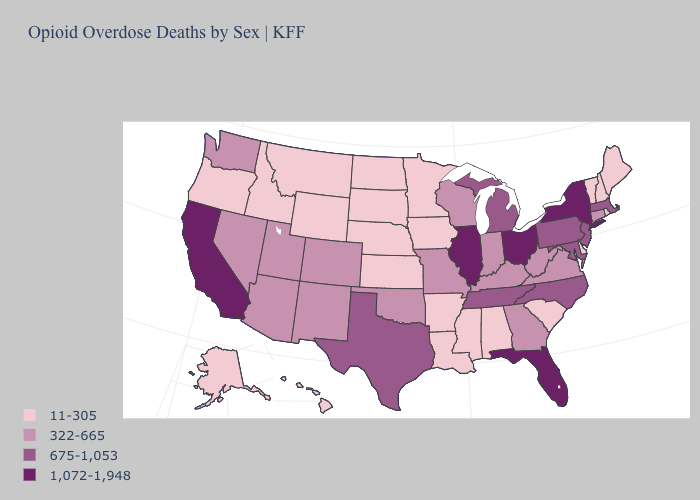Does Texas have the lowest value in the USA?
Be succinct. No. Does Missouri have the same value as Nevada?
Write a very short answer. Yes. What is the highest value in the USA?
Keep it brief. 1,072-1,948. Name the states that have a value in the range 1,072-1,948?
Answer briefly. California, Florida, Illinois, New York, Ohio. Is the legend a continuous bar?
Short answer required. No. Name the states that have a value in the range 675-1,053?
Be succinct. Maryland, Massachusetts, Michigan, New Jersey, North Carolina, Pennsylvania, Tennessee, Texas. Name the states that have a value in the range 1,072-1,948?
Give a very brief answer. California, Florida, Illinois, New York, Ohio. Name the states that have a value in the range 675-1,053?
Concise answer only. Maryland, Massachusetts, Michigan, New Jersey, North Carolina, Pennsylvania, Tennessee, Texas. Does Washington have the lowest value in the West?
Keep it brief. No. Does Colorado have the highest value in the USA?
Short answer required. No. Name the states that have a value in the range 11-305?
Short answer required. Alabama, Alaska, Arkansas, Delaware, Hawaii, Idaho, Iowa, Kansas, Louisiana, Maine, Minnesota, Mississippi, Montana, Nebraska, New Hampshire, North Dakota, Oregon, Rhode Island, South Carolina, South Dakota, Vermont, Wyoming. Among the states that border Nevada , which have the lowest value?
Short answer required. Idaho, Oregon. Name the states that have a value in the range 322-665?
Give a very brief answer. Arizona, Colorado, Connecticut, Georgia, Indiana, Kentucky, Missouri, Nevada, New Mexico, Oklahoma, Utah, Virginia, Washington, West Virginia, Wisconsin. Among the states that border Kentucky , which have the highest value?
Write a very short answer. Illinois, Ohio. Name the states that have a value in the range 675-1,053?
Quick response, please. Maryland, Massachusetts, Michigan, New Jersey, North Carolina, Pennsylvania, Tennessee, Texas. 